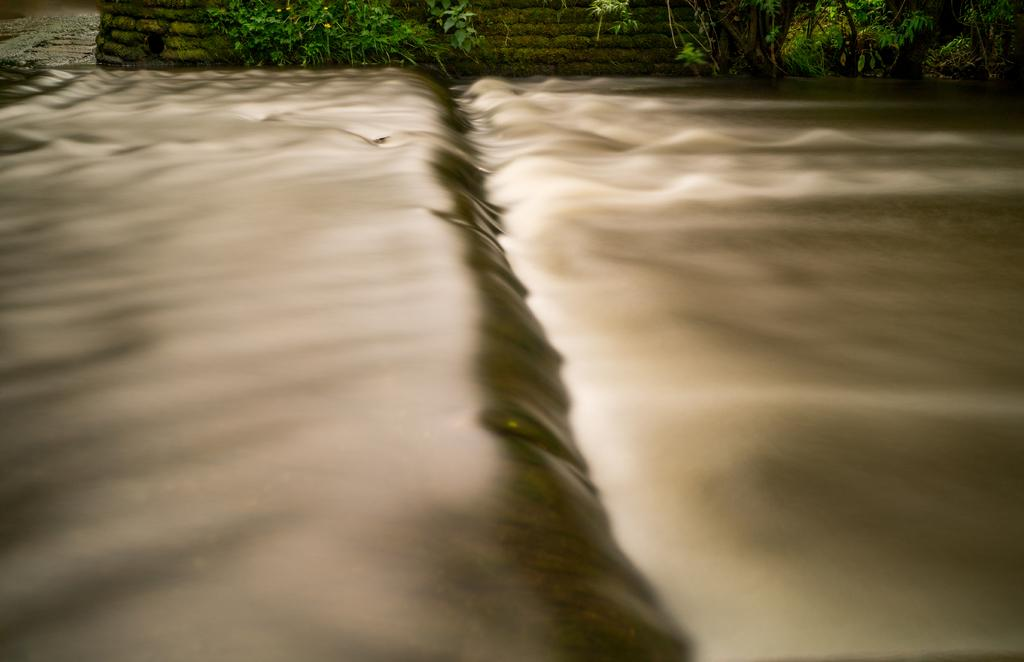What is the terrain like in the image? The land in the image is uneven. What type of plants can be seen in the background of the image? There are plants with yellow flowers in the background of the image. What structure is visible in the background of the image? There is a wall visible in the background of the image. What type of magic is the minister performing in the image? There is no minister or magic present in the image. What is the stem of the plant doing in the image? There is no specific mention of a plant stem in the image, but the plants with yellow flowers are visible. 